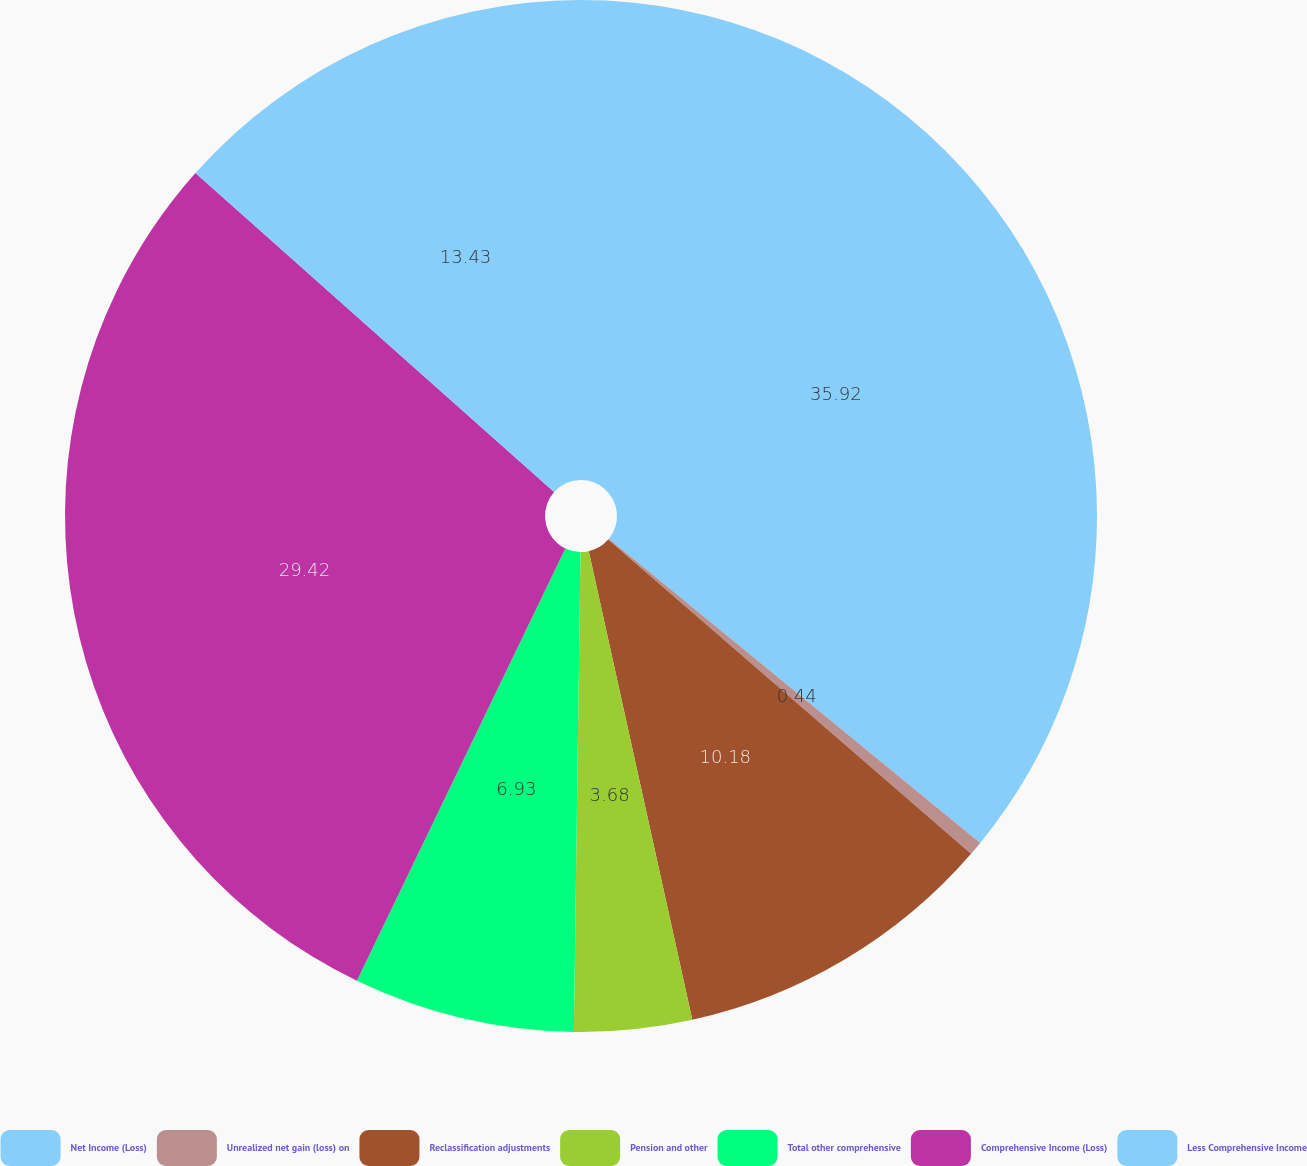Convert chart. <chart><loc_0><loc_0><loc_500><loc_500><pie_chart><fcel>Net Income (Loss)<fcel>Unrealized net gain (loss) on<fcel>Reclassification adjustments<fcel>Pension and other<fcel>Total other comprehensive<fcel>Comprehensive Income (Loss)<fcel>Less Comprehensive Income<nl><fcel>35.92%<fcel>0.44%<fcel>10.18%<fcel>3.68%<fcel>6.93%<fcel>29.42%<fcel>13.43%<nl></chart> 